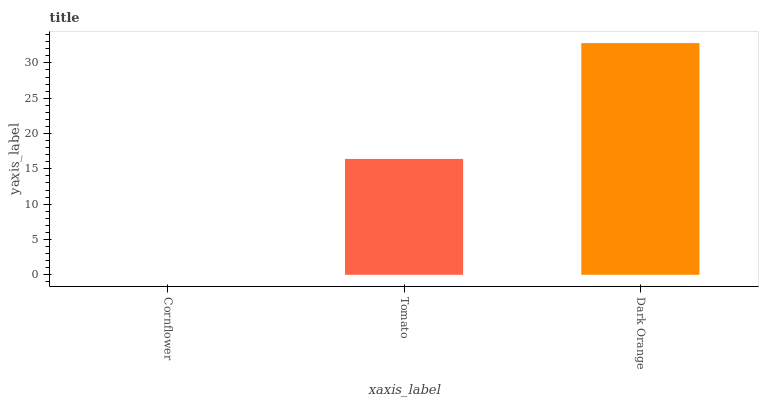Is Cornflower the minimum?
Answer yes or no. Yes. Is Dark Orange the maximum?
Answer yes or no. Yes. Is Tomato the minimum?
Answer yes or no. No. Is Tomato the maximum?
Answer yes or no. No. Is Tomato greater than Cornflower?
Answer yes or no. Yes. Is Cornflower less than Tomato?
Answer yes or no. Yes. Is Cornflower greater than Tomato?
Answer yes or no. No. Is Tomato less than Cornflower?
Answer yes or no. No. Is Tomato the high median?
Answer yes or no. Yes. Is Tomato the low median?
Answer yes or no. Yes. Is Dark Orange the high median?
Answer yes or no. No. Is Cornflower the low median?
Answer yes or no. No. 